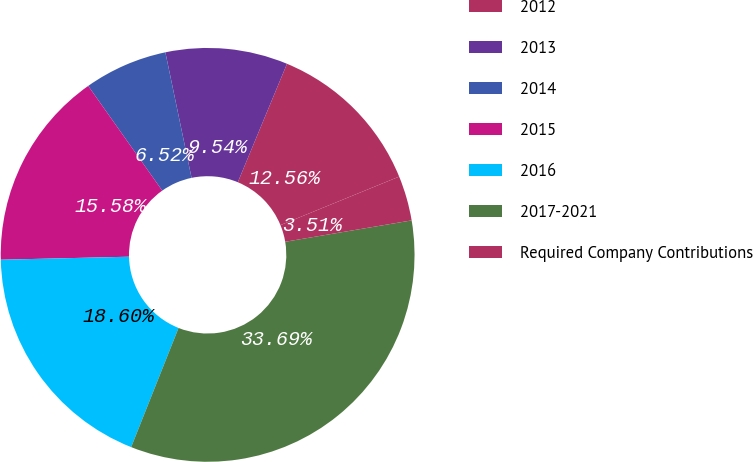Convert chart. <chart><loc_0><loc_0><loc_500><loc_500><pie_chart><fcel>2012<fcel>2013<fcel>2014<fcel>2015<fcel>2016<fcel>2017-2021<fcel>Required Company Contributions<nl><fcel>12.56%<fcel>9.54%<fcel>6.52%<fcel>15.58%<fcel>18.6%<fcel>33.69%<fcel>3.51%<nl></chart> 